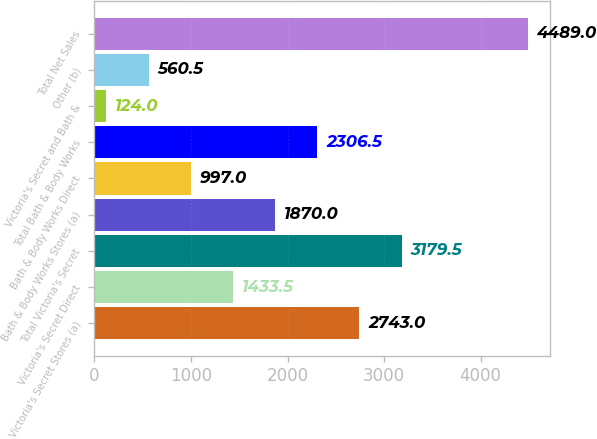<chart> <loc_0><loc_0><loc_500><loc_500><bar_chart><fcel>Victoria's Secret Stores (a)<fcel>Victoria's Secret Direct<fcel>Total Victoria's Secret<fcel>Bath & Body Works Stores (a)<fcel>Bath & Body Works Direct<fcel>Total Bath & Body Works<fcel>Victoria's Secret and Bath &<fcel>Other (b)<fcel>Total Net Sales<nl><fcel>2743<fcel>1433.5<fcel>3179.5<fcel>1870<fcel>997<fcel>2306.5<fcel>124<fcel>560.5<fcel>4489<nl></chart> 